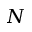<formula> <loc_0><loc_0><loc_500><loc_500>N</formula> 